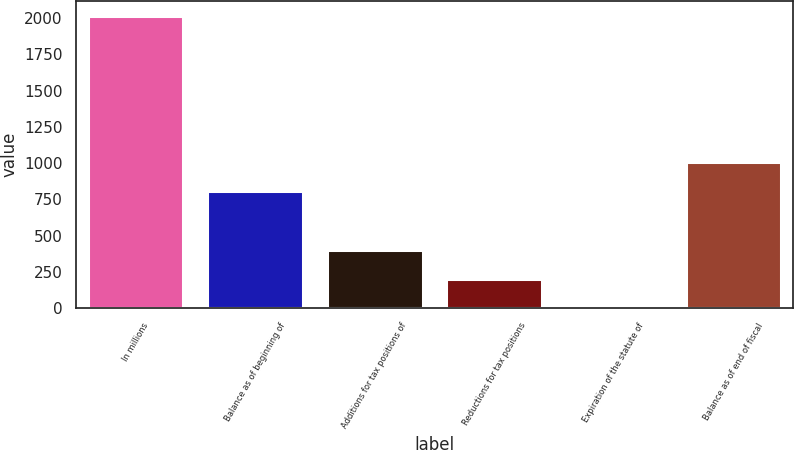Convert chart. <chart><loc_0><loc_0><loc_500><loc_500><bar_chart><fcel>In millions<fcel>Balance as of beginning of<fcel>Additions for tax positions of<fcel>Reductions for tax positions<fcel>Expiration of the statute of<fcel>Balance as of end of fiscal<nl><fcel>2014<fcel>805.78<fcel>403.04<fcel>201.67<fcel>0.3<fcel>1007.15<nl></chart> 